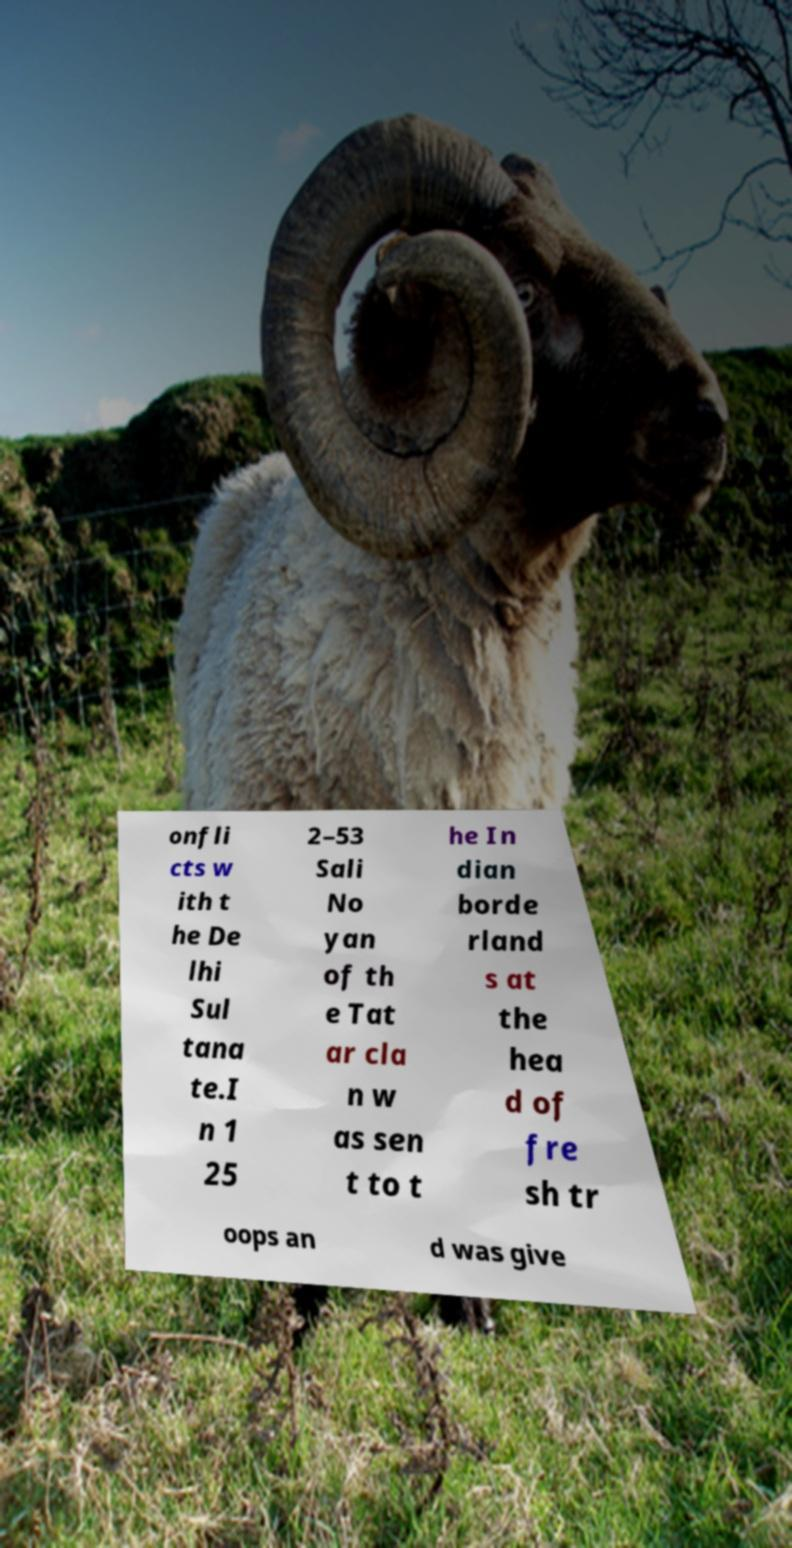For documentation purposes, I need the text within this image transcribed. Could you provide that? onfli cts w ith t he De lhi Sul tana te.I n 1 25 2–53 Sali No yan of th e Tat ar cla n w as sen t to t he In dian borde rland s at the hea d of fre sh tr oops an d was give 